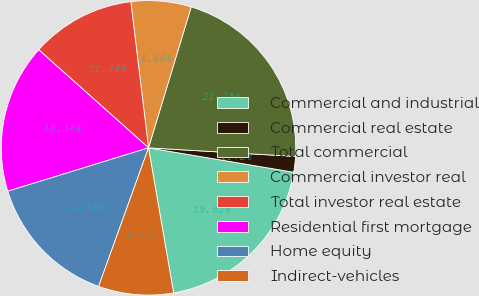<chart> <loc_0><loc_0><loc_500><loc_500><pie_chart><fcel>Commercial and industrial<fcel>Commercial real estate<fcel>Total commercial<fcel>Commercial investor real<fcel>Total investor real estate<fcel>Residential first mortgage<fcel>Home equity<fcel>Indirect-vehicles<nl><fcel>19.62%<fcel>1.72%<fcel>21.25%<fcel>6.6%<fcel>11.48%<fcel>16.36%<fcel>14.74%<fcel>8.23%<nl></chart> 